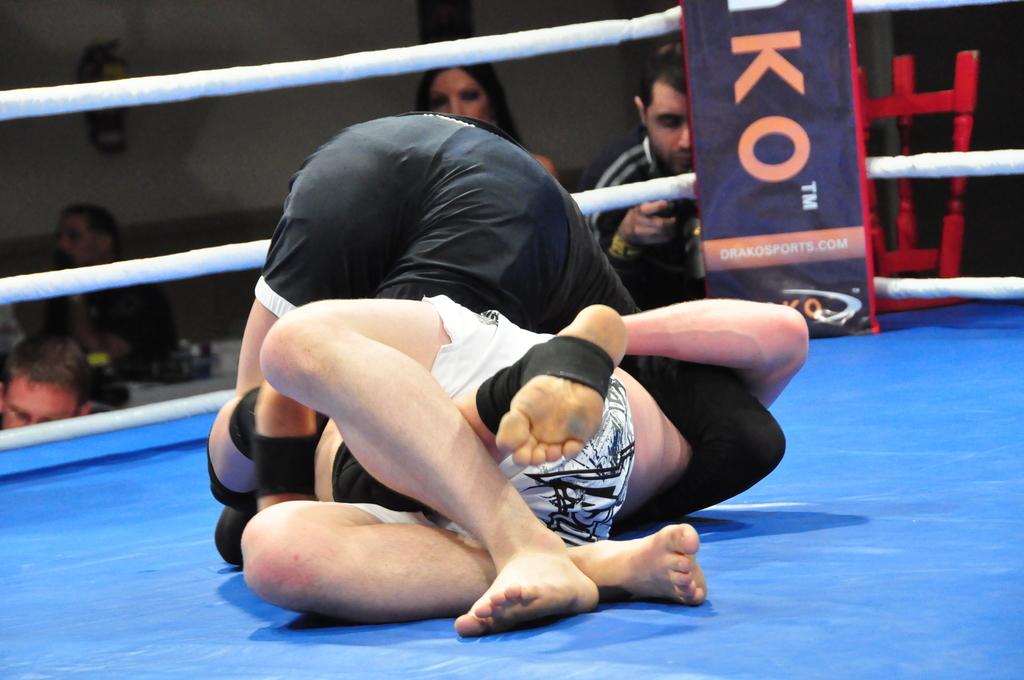What does the rest of the post say?
Your response must be concise. Ko. What website is advertised?
Your answer should be compact. Drakosports.com. 